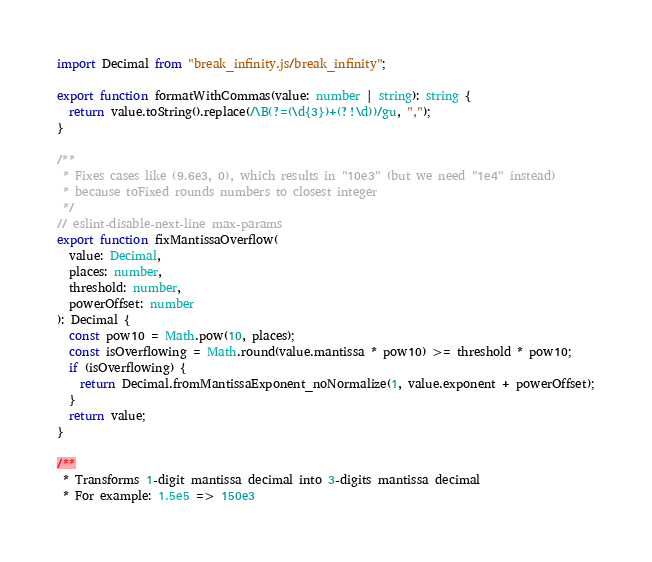Convert code to text. <code><loc_0><loc_0><loc_500><loc_500><_TypeScript_>import Decimal from "break_infinity.js/break_infinity";

export function formatWithCommas(value: number | string): string {
  return value.toString().replace(/\B(?=(\d{3})+(?!\d))/gu, ",");
}

/**
 * Fixes cases like (9.6e3, 0), which results in "10e3" (but we need "1e4" instead)
 * because toFixed rounds numbers to closest integer
 */
// eslint-disable-next-line max-params
export function fixMantissaOverflow(
  value: Decimal,
  places: number,
  threshold: number,
  powerOffset: number
): Decimal {
  const pow10 = Math.pow(10, places);
  const isOverflowing = Math.round(value.mantissa * pow10) >= threshold * pow10;
  if (isOverflowing) {
    return Decimal.fromMantissaExponent_noNormalize(1, value.exponent + powerOffset);
  }
  return value;
}

/**
 * Transforms 1-digit mantissa decimal into 3-digits mantissa decimal
 * For example: 1.5e5 => 150e3</code> 